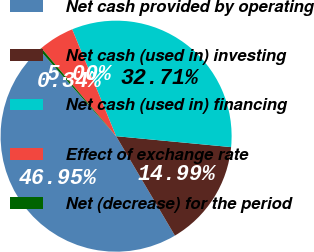Convert chart. <chart><loc_0><loc_0><loc_500><loc_500><pie_chart><fcel>Net cash provided by operating<fcel>Net cash (used in) investing<fcel>Net cash (used in) financing<fcel>Effect of exchange rate<fcel>Net (decrease) for the period<nl><fcel>46.95%<fcel>14.99%<fcel>32.71%<fcel>5.0%<fcel>0.34%<nl></chart> 